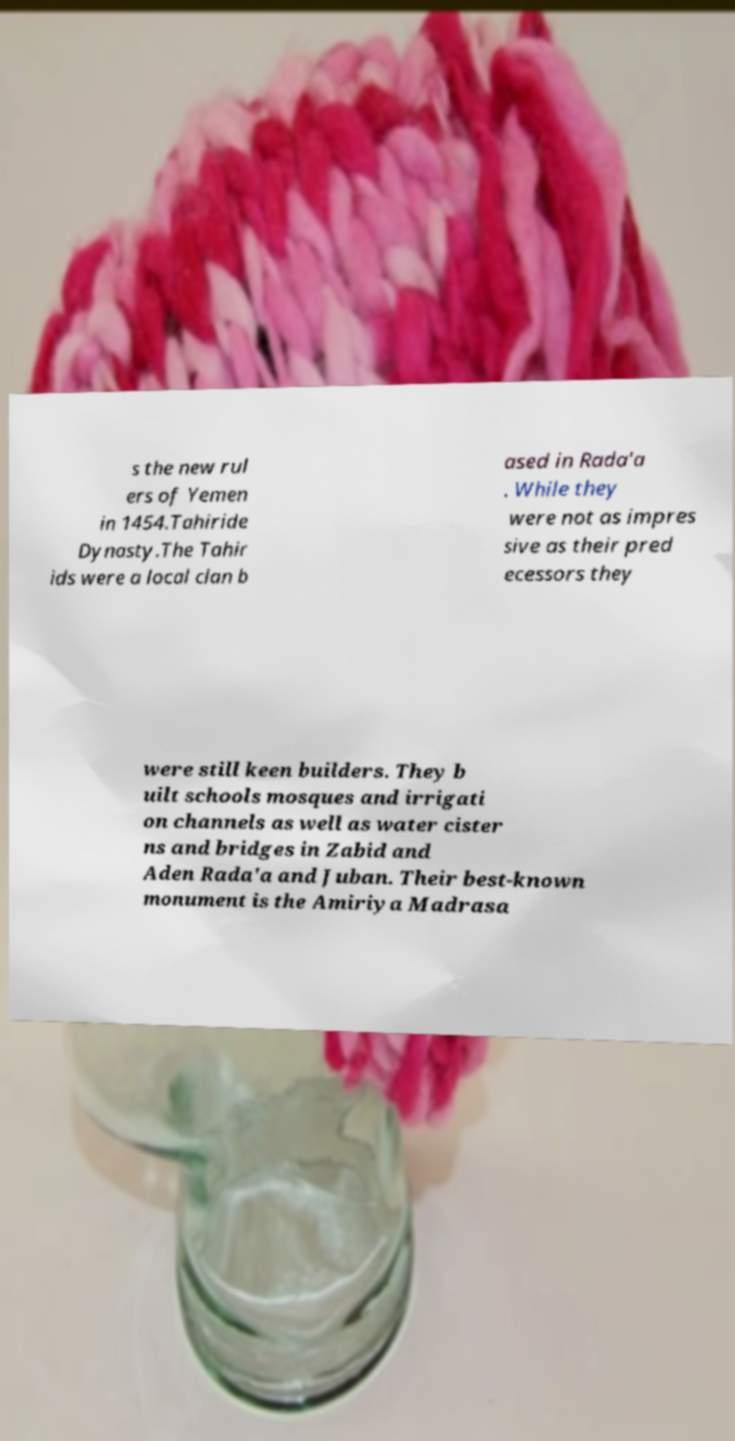I need the written content from this picture converted into text. Can you do that? s the new rul ers of Yemen in 1454.Tahiride Dynasty.The Tahir ids were a local clan b ased in Rada'a . While they were not as impres sive as their pred ecessors they were still keen builders. They b uilt schools mosques and irrigati on channels as well as water cister ns and bridges in Zabid and Aden Rada'a and Juban. Their best-known monument is the Amiriya Madrasa 